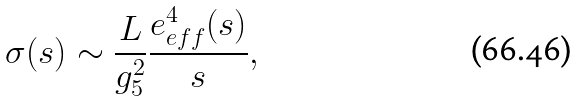Convert formula to latex. <formula><loc_0><loc_0><loc_500><loc_500>\sigma ( s ) \sim { \frac { L } { g _ { 5 } ^ { 2 } } } \frac { e _ { e f f } ^ { 4 } ( s ) } { s } ,</formula> 